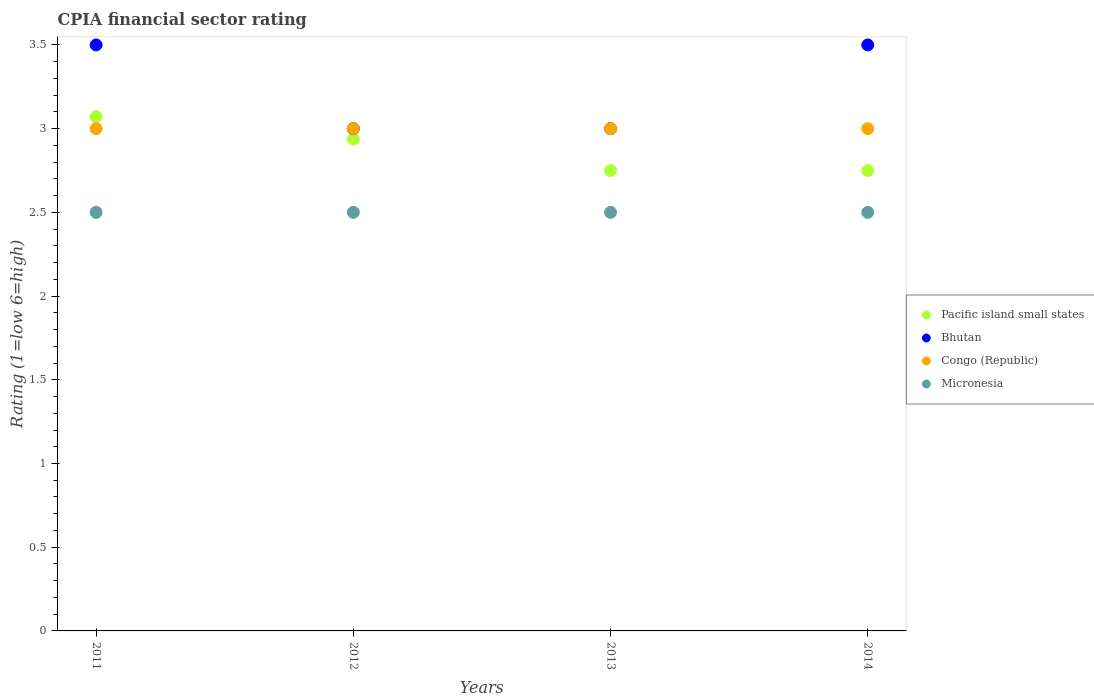How many different coloured dotlines are there?
Keep it short and to the point. 4. Is the number of dotlines equal to the number of legend labels?
Give a very brief answer. Yes. What is the CPIA rating in Micronesia in 2014?
Provide a short and direct response. 2.5. Across all years, what is the maximum CPIA rating in Pacific island small states?
Keep it short and to the point. 3.07. Across all years, what is the minimum CPIA rating in Pacific island small states?
Provide a short and direct response. 2.75. In which year was the CPIA rating in Congo (Republic) minimum?
Give a very brief answer. 2011. What is the total CPIA rating in Pacific island small states in the graph?
Offer a very short reply. 11.51. What is the difference between the CPIA rating in Pacific island small states in 2012 and that in 2013?
Make the answer very short. 0.19. What is the difference between the CPIA rating in Congo (Republic) in 2011 and the CPIA rating in Pacific island small states in 2014?
Provide a short and direct response. 0.25. What is the average CPIA rating in Micronesia per year?
Your answer should be very brief. 2.5. In the year 2014, what is the difference between the CPIA rating in Congo (Republic) and CPIA rating in Pacific island small states?
Keep it short and to the point. 0.25. In how many years, is the CPIA rating in Congo (Republic) greater than 1.3?
Your response must be concise. 4. Is the CPIA rating in Congo (Republic) in 2012 less than that in 2013?
Provide a succinct answer. No. Is the difference between the CPIA rating in Congo (Republic) in 2011 and 2012 greater than the difference between the CPIA rating in Pacific island small states in 2011 and 2012?
Your answer should be very brief. No. In how many years, is the CPIA rating in Micronesia greater than the average CPIA rating in Micronesia taken over all years?
Offer a terse response. 0. Is it the case that in every year, the sum of the CPIA rating in Micronesia and CPIA rating in Bhutan  is greater than the sum of CPIA rating in Pacific island small states and CPIA rating in Congo (Republic)?
Give a very brief answer. No. Is the CPIA rating in Bhutan strictly greater than the CPIA rating in Micronesia over the years?
Give a very brief answer. Yes. Is the CPIA rating in Micronesia strictly less than the CPIA rating in Congo (Republic) over the years?
Keep it short and to the point. Yes. How many dotlines are there?
Offer a terse response. 4. How many years are there in the graph?
Give a very brief answer. 4. What is the difference between two consecutive major ticks on the Y-axis?
Offer a very short reply. 0.5. Are the values on the major ticks of Y-axis written in scientific E-notation?
Make the answer very short. No. Does the graph contain grids?
Keep it short and to the point. No. Where does the legend appear in the graph?
Provide a short and direct response. Center right. How are the legend labels stacked?
Your answer should be very brief. Vertical. What is the title of the graph?
Give a very brief answer. CPIA financial sector rating. Does "Aruba" appear as one of the legend labels in the graph?
Offer a very short reply. No. What is the label or title of the X-axis?
Ensure brevity in your answer.  Years. What is the Rating (1=low 6=high) in Pacific island small states in 2011?
Provide a succinct answer. 3.07. What is the Rating (1=low 6=high) in Bhutan in 2011?
Your response must be concise. 3.5. What is the Rating (1=low 6=high) in Congo (Republic) in 2011?
Make the answer very short. 3. What is the Rating (1=low 6=high) in Micronesia in 2011?
Your answer should be compact. 2.5. What is the Rating (1=low 6=high) of Pacific island small states in 2012?
Your answer should be very brief. 2.94. What is the Rating (1=low 6=high) in Pacific island small states in 2013?
Make the answer very short. 2.75. What is the Rating (1=low 6=high) of Pacific island small states in 2014?
Your answer should be compact. 2.75. Across all years, what is the maximum Rating (1=low 6=high) of Pacific island small states?
Keep it short and to the point. 3.07. Across all years, what is the maximum Rating (1=low 6=high) of Bhutan?
Your response must be concise. 3.5. Across all years, what is the maximum Rating (1=low 6=high) of Congo (Republic)?
Keep it short and to the point. 3. Across all years, what is the minimum Rating (1=low 6=high) in Pacific island small states?
Your answer should be very brief. 2.75. Across all years, what is the minimum Rating (1=low 6=high) of Congo (Republic)?
Keep it short and to the point. 3. Across all years, what is the minimum Rating (1=low 6=high) of Micronesia?
Ensure brevity in your answer.  2.5. What is the total Rating (1=low 6=high) of Pacific island small states in the graph?
Ensure brevity in your answer.  11.51. What is the total Rating (1=low 6=high) of Congo (Republic) in the graph?
Give a very brief answer. 12. What is the total Rating (1=low 6=high) in Micronesia in the graph?
Provide a succinct answer. 10. What is the difference between the Rating (1=low 6=high) of Pacific island small states in 2011 and that in 2012?
Give a very brief answer. 0.13. What is the difference between the Rating (1=low 6=high) in Bhutan in 2011 and that in 2012?
Your response must be concise. 0.5. What is the difference between the Rating (1=low 6=high) of Congo (Republic) in 2011 and that in 2012?
Make the answer very short. 0. What is the difference between the Rating (1=low 6=high) in Pacific island small states in 2011 and that in 2013?
Provide a short and direct response. 0.32. What is the difference between the Rating (1=low 6=high) of Pacific island small states in 2011 and that in 2014?
Offer a very short reply. 0.32. What is the difference between the Rating (1=low 6=high) in Pacific island small states in 2012 and that in 2013?
Your response must be concise. 0.19. What is the difference between the Rating (1=low 6=high) in Congo (Republic) in 2012 and that in 2013?
Offer a terse response. 0. What is the difference between the Rating (1=low 6=high) in Micronesia in 2012 and that in 2013?
Your response must be concise. 0. What is the difference between the Rating (1=low 6=high) in Pacific island small states in 2012 and that in 2014?
Provide a short and direct response. 0.19. What is the difference between the Rating (1=low 6=high) in Micronesia in 2012 and that in 2014?
Your answer should be very brief. 0. What is the difference between the Rating (1=low 6=high) in Pacific island small states in 2013 and that in 2014?
Offer a terse response. 0. What is the difference between the Rating (1=low 6=high) of Bhutan in 2013 and that in 2014?
Your answer should be very brief. -0.5. What is the difference between the Rating (1=low 6=high) of Congo (Republic) in 2013 and that in 2014?
Offer a terse response. 0. What is the difference between the Rating (1=low 6=high) in Micronesia in 2013 and that in 2014?
Your response must be concise. 0. What is the difference between the Rating (1=low 6=high) in Pacific island small states in 2011 and the Rating (1=low 6=high) in Bhutan in 2012?
Your response must be concise. 0.07. What is the difference between the Rating (1=low 6=high) in Pacific island small states in 2011 and the Rating (1=low 6=high) in Congo (Republic) in 2012?
Ensure brevity in your answer.  0.07. What is the difference between the Rating (1=low 6=high) in Congo (Republic) in 2011 and the Rating (1=low 6=high) in Micronesia in 2012?
Give a very brief answer. 0.5. What is the difference between the Rating (1=low 6=high) of Pacific island small states in 2011 and the Rating (1=low 6=high) of Bhutan in 2013?
Offer a terse response. 0.07. What is the difference between the Rating (1=low 6=high) of Pacific island small states in 2011 and the Rating (1=low 6=high) of Congo (Republic) in 2013?
Offer a terse response. 0.07. What is the difference between the Rating (1=low 6=high) of Bhutan in 2011 and the Rating (1=low 6=high) of Congo (Republic) in 2013?
Give a very brief answer. 0.5. What is the difference between the Rating (1=low 6=high) of Pacific island small states in 2011 and the Rating (1=low 6=high) of Bhutan in 2014?
Your response must be concise. -0.43. What is the difference between the Rating (1=low 6=high) in Pacific island small states in 2011 and the Rating (1=low 6=high) in Congo (Republic) in 2014?
Provide a short and direct response. 0.07. What is the difference between the Rating (1=low 6=high) of Pacific island small states in 2011 and the Rating (1=low 6=high) of Micronesia in 2014?
Your answer should be very brief. 0.57. What is the difference between the Rating (1=low 6=high) in Bhutan in 2011 and the Rating (1=low 6=high) in Congo (Republic) in 2014?
Offer a very short reply. 0.5. What is the difference between the Rating (1=low 6=high) of Bhutan in 2011 and the Rating (1=low 6=high) of Micronesia in 2014?
Provide a succinct answer. 1. What is the difference between the Rating (1=low 6=high) of Congo (Republic) in 2011 and the Rating (1=low 6=high) of Micronesia in 2014?
Offer a very short reply. 0.5. What is the difference between the Rating (1=low 6=high) of Pacific island small states in 2012 and the Rating (1=low 6=high) of Bhutan in 2013?
Your answer should be compact. -0.06. What is the difference between the Rating (1=low 6=high) of Pacific island small states in 2012 and the Rating (1=low 6=high) of Congo (Republic) in 2013?
Make the answer very short. -0.06. What is the difference between the Rating (1=low 6=high) in Pacific island small states in 2012 and the Rating (1=low 6=high) in Micronesia in 2013?
Provide a succinct answer. 0.44. What is the difference between the Rating (1=low 6=high) in Bhutan in 2012 and the Rating (1=low 6=high) in Micronesia in 2013?
Offer a very short reply. 0.5. What is the difference between the Rating (1=low 6=high) in Pacific island small states in 2012 and the Rating (1=low 6=high) in Bhutan in 2014?
Offer a very short reply. -0.56. What is the difference between the Rating (1=low 6=high) of Pacific island small states in 2012 and the Rating (1=low 6=high) of Congo (Republic) in 2014?
Keep it short and to the point. -0.06. What is the difference between the Rating (1=low 6=high) of Pacific island small states in 2012 and the Rating (1=low 6=high) of Micronesia in 2014?
Make the answer very short. 0.44. What is the difference between the Rating (1=low 6=high) in Bhutan in 2012 and the Rating (1=low 6=high) in Micronesia in 2014?
Give a very brief answer. 0.5. What is the difference between the Rating (1=low 6=high) in Pacific island small states in 2013 and the Rating (1=low 6=high) in Bhutan in 2014?
Your answer should be compact. -0.75. What is the difference between the Rating (1=low 6=high) in Pacific island small states in 2013 and the Rating (1=low 6=high) in Congo (Republic) in 2014?
Provide a succinct answer. -0.25. What is the difference between the Rating (1=low 6=high) of Bhutan in 2013 and the Rating (1=low 6=high) of Micronesia in 2014?
Provide a succinct answer. 0.5. What is the difference between the Rating (1=low 6=high) of Congo (Republic) in 2013 and the Rating (1=low 6=high) of Micronesia in 2014?
Provide a succinct answer. 0.5. What is the average Rating (1=low 6=high) in Pacific island small states per year?
Your answer should be compact. 2.88. What is the average Rating (1=low 6=high) in Bhutan per year?
Provide a succinct answer. 3.25. What is the average Rating (1=low 6=high) of Congo (Republic) per year?
Keep it short and to the point. 3. What is the average Rating (1=low 6=high) in Micronesia per year?
Your answer should be very brief. 2.5. In the year 2011, what is the difference between the Rating (1=low 6=high) in Pacific island small states and Rating (1=low 6=high) in Bhutan?
Offer a terse response. -0.43. In the year 2011, what is the difference between the Rating (1=low 6=high) of Pacific island small states and Rating (1=low 6=high) of Congo (Republic)?
Your answer should be compact. 0.07. In the year 2011, what is the difference between the Rating (1=low 6=high) of Bhutan and Rating (1=low 6=high) of Micronesia?
Your answer should be very brief. 1. In the year 2011, what is the difference between the Rating (1=low 6=high) of Congo (Republic) and Rating (1=low 6=high) of Micronesia?
Provide a succinct answer. 0.5. In the year 2012, what is the difference between the Rating (1=low 6=high) in Pacific island small states and Rating (1=low 6=high) in Bhutan?
Keep it short and to the point. -0.06. In the year 2012, what is the difference between the Rating (1=low 6=high) in Pacific island small states and Rating (1=low 6=high) in Congo (Republic)?
Make the answer very short. -0.06. In the year 2012, what is the difference between the Rating (1=low 6=high) in Pacific island small states and Rating (1=low 6=high) in Micronesia?
Ensure brevity in your answer.  0.44. In the year 2013, what is the difference between the Rating (1=low 6=high) in Pacific island small states and Rating (1=low 6=high) in Congo (Republic)?
Offer a terse response. -0.25. In the year 2013, what is the difference between the Rating (1=low 6=high) in Bhutan and Rating (1=low 6=high) in Congo (Republic)?
Keep it short and to the point. 0. In the year 2013, what is the difference between the Rating (1=low 6=high) of Bhutan and Rating (1=low 6=high) of Micronesia?
Your response must be concise. 0.5. In the year 2014, what is the difference between the Rating (1=low 6=high) of Pacific island small states and Rating (1=low 6=high) of Bhutan?
Your response must be concise. -0.75. In the year 2014, what is the difference between the Rating (1=low 6=high) in Pacific island small states and Rating (1=low 6=high) in Congo (Republic)?
Offer a terse response. -0.25. In the year 2014, what is the difference between the Rating (1=low 6=high) of Bhutan and Rating (1=low 6=high) of Congo (Republic)?
Provide a short and direct response. 0.5. In the year 2014, what is the difference between the Rating (1=low 6=high) in Congo (Republic) and Rating (1=low 6=high) in Micronesia?
Offer a very short reply. 0.5. What is the ratio of the Rating (1=low 6=high) of Pacific island small states in 2011 to that in 2012?
Make the answer very short. 1.05. What is the ratio of the Rating (1=low 6=high) of Congo (Republic) in 2011 to that in 2012?
Your response must be concise. 1. What is the ratio of the Rating (1=low 6=high) in Micronesia in 2011 to that in 2012?
Your response must be concise. 1. What is the ratio of the Rating (1=low 6=high) of Pacific island small states in 2011 to that in 2013?
Offer a very short reply. 1.12. What is the ratio of the Rating (1=low 6=high) of Bhutan in 2011 to that in 2013?
Your answer should be very brief. 1.17. What is the ratio of the Rating (1=low 6=high) of Congo (Republic) in 2011 to that in 2013?
Offer a terse response. 1. What is the ratio of the Rating (1=low 6=high) of Pacific island small states in 2011 to that in 2014?
Ensure brevity in your answer.  1.12. What is the ratio of the Rating (1=low 6=high) of Congo (Republic) in 2011 to that in 2014?
Offer a very short reply. 1. What is the ratio of the Rating (1=low 6=high) of Pacific island small states in 2012 to that in 2013?
Your answer should be very brief. 1.07. What is the ratio of the Rating (1=low 6=high) in Pacific island small states in 2012 to that in 2014?
Make the answer very short. 1.07. What is the ratio of the Rating (1=low 6=high) of Congo (Republic) in 2012 to that in 2014?
Provide a short and direct response. 1. What is the ratio of the Rating (1=low 6=high) of Micronesia in 2013 to that in 2014?
Ensure brevity in your answer.  1. What is the difference between the highest and the second highest Rating (1=low 6=high) of Pacific island small states?
Give a very brief answer. 0.13. What is the difference between the highest and the second highest Rating (1=low 6=high) of Micronesia?
Your answer should be compact. 0. What is the difference between the highest and the lowest Rating (1=low 6=high) of Pacific island small states?
Make the answer very short. 0.32. What is the difference between the highest and the lowest Rating (1=low 6=high) in Bhutan?
Offer a very short reply. 0.5. What is the difference between the highest and the lowest Rating (1=low 6=high) in Congo (Republic)?
Provide a succinct answer. 0. What is the difference between the highest and the lowest Rating (1=low 6=high) in Micronesia?
Provide a succinct answer. 0. 